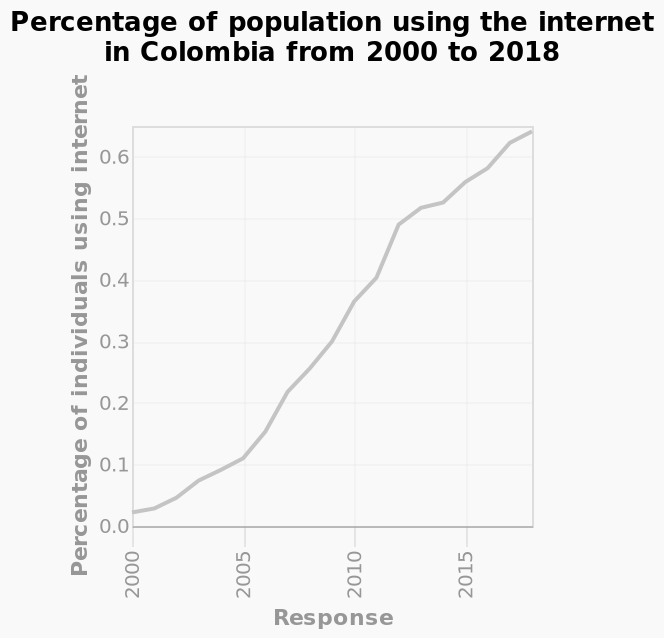<image>
Can the increase in responses be counted towards the overall increase?  Yes, the increase in responses can be counted towards the overall increase. Is the percentage of people using the internet increasing?  Yes, the percentage of people using the internet is increasing. Does the increase in internet users directly correlate with the increase in responses?  There is a correlation between the increase in internet users and the increase in responses, but it may not be a direct relationship. What is the range of the y-axis on the line diagram?  The range of the y-axis on the line diagram is 0.0 to 0.6. 